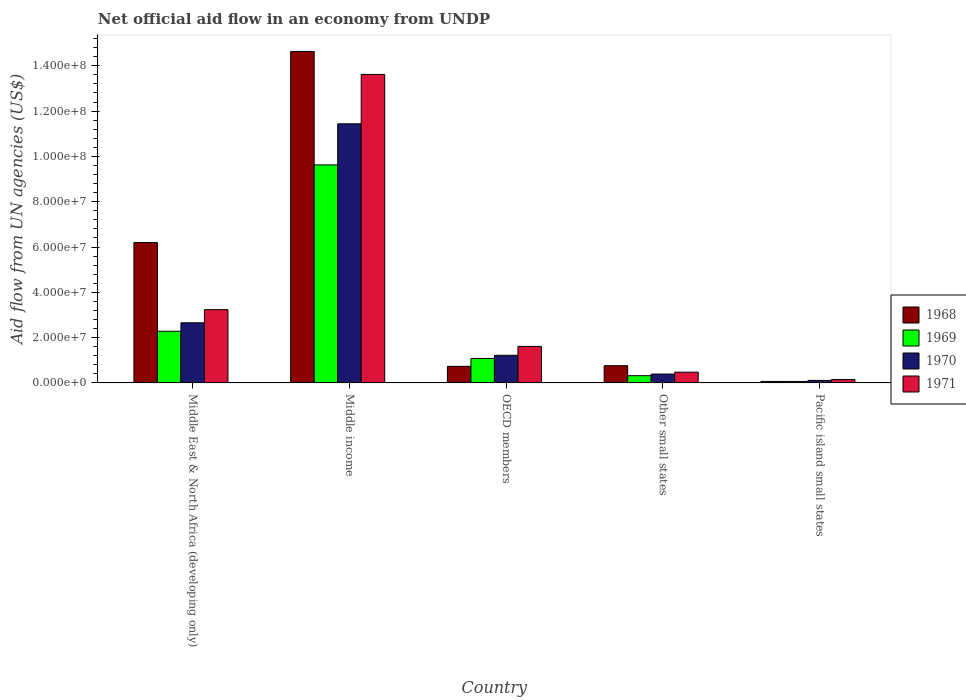How many different coloured bars are there?
Make the answer very short. 4. How many groups of bars are there?
Ensure brevity in your answer.  5. Are the number of bars per tick equal to the number of legend labels?
Ensure brevity in your answer.  Yes. Are the number of bars on each tick of the X-axis equal?
Keep it short and to the point. Yes. What is the label of the 5th group of bars from the left?
Offer a very short reply. Pacific island small states. In how many cases, is the number of bars for a given country not equal to the number of legend labels?
Offer a very short reply. 0. What is the net official aid flow in 1970 in Middle East & North Africa (developing only)?
Give a very brief answer. 2.66e+07. Across all countries, what is the maximum net official aid flow in 1970?
Ensure brevity in your answer.  1.14e+08. In which country was the net official aid flow in 1968 minimum?
Your response must be concise. Pacific island small states. What is the total net official aid flow in 1971 in the graph?
Keep it short and to the point. 1.91e+08. What is the difference between the net official aid flow in 1970 in Middle income and that in Other small states?
Keep it short and to the point. 1.10e+08. What is the difference between the net official aid flow in 1969 in Other small states and the net official aid flow in 1968 in Middle income?
Provide a short and direct response. -1.43e+08. What is the average net official aid flow in 1971 per country?
Provide a succinct answer. 3.82e+07. What is the difference between the net official aid flow of/in 1968 and net official aid flow of/in 1971 in Middle East & North Africa (developing only)?
Your response must be concise. 2.96e+07. In how many countries, is the net official aid flow in 1971 greater than 32000000 US$?
Your answer should be very brief. 2. What is the ratio of the net official aid flow in 1970 in Middle East & North Africa (developing only) to that in OECD members?
Keep it short and to the point. 2.18. Is the net official aid flow in 1969 in Other small states less than that in Pacific island small states?
Your answer should be compact. No. Is the difference between the net official aid flow in 1968 in Other small states and Pacific island small states greater than the difference between the net official aid flow in 1971 in Other small states and Pacific island small states?
Offer a terse response. Yes. What is the difference between the highest and the second highest net official aid flow in 1970?
Provide a short and direct response. 1.02e+08. What is the difference between the highest and the lowest net official aid flow in 1970?
Keep it short and to the point. 1.13e+08. What does the 3rd bar from the left in Pacific island small states represents?
Provide a succinct answer. 1970. What does the 3rd bar from the right in Pacific island small states represents?
Make the answer very short. 1969. How many countries are there in the graph?
Offer a very short reply. 5. How many legend labels are there?
Keep it short and to the point. 4. How are the legend labels stacked?
Make the answer very short. Vertical. What is the title of the graph?
Offer a terse response. Net official aid flow in an economy from UNDP. Does "2007" appear as one of the legend labels in the graph?
Offer a very short reply. No. What is the label or title of the X-axis?
Offer a very short reply. Country. What is the label or title of the Y-axis?
Provide a short and direct response. Aid flow from UN agencies (US$). What is the Aid flow from UN agencies (US$) of 1968 in Middle East & North Africa (developing only)?
Provide a short and direct response. 6.20e+07. What is the Aid flow from UN agencies (US$) of 1969 in Middle East & North Africa (developing only)?
Your answer should be very brief. 2.28e+07. What is the Aid flow from UN agencies (US$) in 1970 in Middle East & North Africa (developing only)?
Your response must be concise. 2.66e+07. What is the Aid flow from UN agencies (US$) of 1971 in Middle East & North Africa (developing only)?
Give a very brief answer. 3.24e+07. What is the Aid flow from UN agencies (US$) of 1968 in Middle income?
Offer a terse response. 1.46e+08. What is the Aid flow from UN agencies (US$) in 1969 in Middle income?
Offer a very short reply. 9.62e+07. What is the Aid flow from UN agencies (US$) of 1970 in Middle income?
Make the answer very short. 1.14e+08. What is the Aid flow from UN agencies (US$) in 1971 in Middle income?
Provide a succinct answer. 1.36e+08. What is the Aid flow from UN agencies (US$) in 1968 in OECD members?
Your answer should be very brief. 7.34e+06. What is the Aid flow from UN agencies (US$) in 1969 in OECD members?
Keep it short and to the point. 1.08e+07. What is the Aid flow from UN agencies (US$) of 1970 in OECD members?
Keep it short and to the point. 1.22e+07. What is the Aid flow from UN agencies (US$) of 1971 in OECD members?
Your response must be concise. 1.61e+07. What is the Aid flow from UN agencies (US$) in 1968 in Other small states?
Your response must be concise. 7.61e+06. What is the Aid flow from UN agencies (US$) of 1969 in Other small states?
Ensure brevity in your answer.  3.20e+06. What is the Aid flow from UN agencies (US$) in 1970 in Other small states?
Your answer should be compact. 3.93e+06. What is the Aid flow from UN agencies (US$) in 1971 in Other small states?
Provide a succinct answer. 4.76e+06. What is the Aid flow from UN agencies (US$) in 1968 in Pacific island small states?
Keep it short and to the point. 6.70e+05. What is the Aid flow from UN agencies (US$) of 1970 in Pacific island small states?
Keep it short and to the point. 1.12e+06. What is the Aid flow from UN agencies (US$) of 1971 in Pacific island small states?
Offer a terse response. 1.50e+06. Across all countries, what is the maximum Aid flow from UN agencies (US$) in 1968?
Make the answer very short. 1.46e+08. Across all countries, what is the maximum Aid flow from UN agencies (US$) of 1969?
Ensure brevity in your answer.  9.62e+07. Across all countries, what is the maximum Aid flow from UN agencies (US$) of 1970?
Offer a terse response. 1.14e+08. Across all countries, what is the maximum Aid flow from UN agencies (US$) in 1971?
Provide a succinct answer. 1.36e+08. Across all countries, what is the minimum Aid flow from UN agencies (US$) of 1968?
Provide a succinct answer. 6.70e+05. Across all countries, what is the minimum Aid flow from UN agencies (US$) of 1969?
Keep it short and to the point. 6.60e+05. Across all countries, what is the minimum Aid flow from UN agencies (US$) of 1970?
Offer a terse response. 1.12e+06. Across all countries, what is the minimum Aid flow from UN agencies (US$) in 1971?
Make the answer very short. 1.50e+06. What is the total Aid flow from UN agencies (US$) of 1968 in the graph?
Make the answer very short. 2.24e+08. What is the total Aid flow from UN agencies (US$) of 1969 in the graph?
Your answer should be very brief. 1.34e+08. What is the total Aid flow from UN agencies (US$) of 1970 in the graph?
Your response must be concise. 1.58e+08. What is the total Aid flow from UN agencies (US$) of 1971 in the graph?
Offer a terse response. 1.91e+08. What is the difference between the Aid flow from UN agencies (US$) in 1968 in Middle East & North Africa (developing only) and that in Middle income?
Your answer should be compact. -8.44e+07. What is the difference between the Aid flow from UN agencies (US$) in 1969 in Middle East & North Africa (developing only) and that in Middle income?
Provide a succinct answer. -7.34e+07. What is the difference between the Aid flow from UN agencies (US$) of 1970 in Middle East & North Africa (developing only) and that in Middle income?
Offer a terse response. -8.78e+07. What is the difference between the Aid flow from UN agencies (US$) in 1971 in Middle East & North Africa (developing only) and that in Middle income?
Your answer should be very brief. -1.04e+08. What is the difference between the Aid flow from UN agencies (US$) in 1968 in Middle East & North Africa (developing only) and that in OECD members?
Provide a short and direct response. 5.46e+07. What is the difference between the Aid flow from UN agencies (US$) of 1969 in Middle East & North Africa (developing only) and that in OECD members?
Ensure brevity in your answer.  1.20e+07. What is the difference between the Aid flow from UN agencies (US$) in 1970 in Middle East & North Africa (developing only) and that in OECD members?
Your answer should be very brief. 1.44e+07. What is the difference between the Aid flow from UN agencies (US$) in 1971 in Middle East & North Africa (developing only) and that in OECD members?
Give a very brief answer. 1.62e+07. What is the difference between the Aid flow from UN agencies (US$) of 1968 in Middle East & North Africa (developing only) and that in Other small states?
Provide a short and direct response. 5.44e+07. What is the difference between the Aid flow from UN agencies (US$) in 1969 in Middle East & North Africa (developing only) and that in Other small states?
Offer a terse response. 1.96e+07. What is the difference between the Aid flow from UN agencies (US$) in 1970 in Middle East & North Africa (developing only) and that in Other small states?
Provide a short and direct response. 2.26e+07. What is the difference between the Aid flow from UN agencies (US$) in 1971 in Middle East & North Africa (developing only) and that in Other small states?
Ensure brevity in your answer.  2.76e+07. What is the difference between the Aid flow from UN agencies (US$) of 1968 in Middle East & North Africa (developing only) and that in Pacific island small states?
Provide a short and direct response. 6.13e+07. What is the difference between the Aid flow from UN agencies (US$) in 1969 in Middle East & North Africa (developing only) and that in Pacific island small states?
Make the answer very short. 2.22e+07. What is the difference between the Aid flow from UN agencies (US$) in 1970 in Middle East & North Africa (developing only) and that in Pacific island small states?
Make the answer very short. 2.54e+07. What is the difference between the Aid flow from UN agencies (US$) of 1971 in Middle East & North Africa (developing only) and that in Pacific island small states?
Offer a very short reply. 3.09e+07. What is the difference between the Aid flow from UN agencies (US$) in 1968 in Middle income and that in OECD members?
Give a very brief answer. 1.39e+08. What is the difference between the Aid flow from UN agencies (US$) in 1969 in Middle income and that in OECD members?
Offer a very short reply. 8.54e+07. What is the difference between the Aid flow from UN agencies (US$) in 1970 in Middle income and that in OECD members?
Offer a very short reply. 1.02e+08. What is the difference between the Aid flow from UN agencies (US$) of 1971 in Middle income and that in OECD members?
Provide a short and direct response. 1.20e+08. What is the difference between the Aid flow from UN agencies (US$) in 1968 in Middle income and that in Other small states?
Keep it short and to the point. 1.39e+08. What is the difference between the Aid flow from UN agencies (US$) of 1969 in Middle income and that in Other small states?
Offer a terse response. 9.30e+07. What is the difference between the Aid flow from UN agencies (US$) in 1970 in Middle income and that in Other small states?
Keep it short and to the point. 1.10e+08. What is the difference between the Aid flow from UN agencies (US$) of 1971 in Middle income and that in Other small states?
Your answer should be compact. 1.31e+08. What is the difference between the Aid flow from UN agencies (US$) in 1968 in Middle income and that in Pacific island small states?
Give a very brief answer. 1.46e+08. What is the difference between the Aid flow from UN agencies (US$) in 1969 in Middle income and that in Pacific island small states?
Keep it short and to the point. 9.56e+07. What is the difference between the Aid flow from UN agencies (US$) in 1970 in Middle income and that in Pacific island small states?
Provide a succinct answer. 1.13e+08. What is the difference between the Aid flow from UN agencies (US$) in 1971 in Middle income and that in Pacific island small states?
Offer a very short reply. 1.35e+08. What is the difference between the Aid flow from UN agencies (US$) of 1968 in OECD members and that in Other small states?
Your answer should be compact. -2.70e+05. What is the difference between the Aid flow from UN agencies (US$) in 1969 in OECD members and that in Other small states?
Give a very brief answer. 7.61e+06. What is the difference between the Aid flow from UN agencies (US$) of 1970 in OECD members and that in Other small states?
Give a very brief answer. 8.27e+06. What is the difference between the Aid flow from UN agencies (US$) in 1971 in OECD members and that in Other small states?
Provide a succinct answer. 1.14e+07. What is the difference between the Aid flow from UN agencies (US$) in 1968 in OECD members and that in Pacific island small states?
Provide a succinct answer. 6.67e+06. What is the difference between the Aid flow from UN agencies (US$) of 1969 in OECD members and that in Pacific island small states?
Provide a succinct answer. 1.02e+07. What is the difference between the Aid flow from UN agencies (US$) of 1970 in OECD members and that in Pacific island small states?
Offer a terse response. 1.11e+07. What is the difference between the Aid flow from UN agencies (US$) of 1971 in OECD members and that in Pacific island small states?
Keep it short and to the point. 1.46e+07. What is the difference between the Aid flow from UN agencies (US$) in 1968 in Other small states and that in Pacific island small states?
Your answer should be compact. 6.94e+06. What is the difference between the Aid flow from UN agencies (US$) of 1969 in Other small states and that in Pacific island small states?
Provide a short and direct response. 2.54e+06. What is the difference between the Aid flow from UN agencies (US$) of 1970 in Other small states and that in Pacific island small states?
Make the answer very short. 2.81e+06. What is the difference between the Aid flow from UN agencies (US$) of 1971 in Other small states and that in Pacific island small states?
Your answer should be very brief. 3.26e+06. What is the difference between the Aid flow from UN agencies (US$) in 1968 in Middle East & North Africa (developing only) and the Aid flow from UN agencies (US$) in 1969 in Middle income?
Keep it short and to the point. -3.43e+07. What is the difference between the Aid flow from UN agencies (US$) in 1968 in Middle East & North Africa (developing only) and the Aid flow from UN agencies (US$) in 1970 in Middle income?
Make the answer very short. -5.24e+07. What is the difference between the Aid flow from UN agencies (US$) of 1968 in Middle East & North Africa (developing only) and the Aid flow from UN agencies (US$) of 1971 in Middle income?
Give a very brief answer. -7.42e+07. What is the difference between the Aid flow from UN agencies (US$) in 1969 in Middle East & North Africa (developing only) and the Aid flow from UN agencies (US$) in 1970 in Middle income?
Provide a succinct answer. -9.16e+07. What is the difference between the Aid flow from UN agencies (US$) of 1969 in Middle East & North Africa (developing only) and the Aid flow from UN agencies (US$) of 1971 in Middle income?
Give a very brief answer. -1.13e+08. What is the difference between the Aid flow from UN agencies (US$) in 1970 in Middle East & North Africa (developing only) and the Aid flow from UN agencies (US$) in 1971 in Middle income?
Your answer should be very brief. -1.10e+08. What is the difference between the Aid flow from UN agencies (US$) of 1968 in Middle East & North Africa (developing only) and the Aid flow from UN agencies (US$) of 1969 in OECD members?
Make the answer very short. 5.12e+07. What is the difference between the Aid flow from UN agencies (US$) in 1968 in Middle East & North Africa (developing only) and the Aid flow from UN agencies (US$) in 1970 in OECD members?
Offer a very short reply. 4.98e+07. What is the difference between the Aid flow from UN agencies (US$) of 1968 in Middle East & North Africa (developing only) and the Aid flow from UN agencies (US$) of 1971 in OECD members?
Keep it short and to the point. 4.58e+07. What is the difference between the Aid flow from UN agencies (US$) in 1969 in Middle East & North Africa (developing only) and the Aid flow from UN agencies (US$) in 1970 in OECD members?
Give a very brief answer. 1.06e+07. What is the difference between the Aid flow from UN agencies (US$) of 1969 in Middle East & North Africa (developing only) and the Aid flow from UN agencies (US$) of 1971 in OECD members?
Offer a terse response. 6.69e+06. What is the difference between the Aid flow from UN agencies (US$) in 1970 in Middle East & North Africa (developing only) and the Aid flow from UN agencies (US$) in 1971 in OECD members?
Give a very brief answer. 1.04e+07. What is the difference between the Aid flow from UN agencies (US$) of 1968 in Middle East & North Africa (developing only) and the Aid flow from UN agencies (US$) of 1969 in Other small states?
Offer a terse response. 5.88e+07. What is the difference between the Aid flow from UN agencies (US$) in 1968 in Middle East & North Africa (developing only) and the Aid flow from UN agencies (US$) in 1970 in Other small states?
Give a very brief answer. 5.80e+07. What is the difference between the Aid flow from UN agencies (US$) of 1968 in Middle East & North Africa (developing only) and the Aid flow from UN agencies (US$) of 1971 in Other small states?
Make the answer very short. 5.72e+07. What is the difference between the Aid flow from UN agencies (US$) in 1969 in Middle East & North Africa (developing only) and the Aid flow from UN agencies (US$) in 1970 in Other small states?
Give a very brief answer. 1.89e+07. What is the difference between the Aid flow from UN agencies (US$) in 1969 in Middle East & North Africa (developing only) and the Aid flow from UN agencies (US$) in 1971 in Other small states?
Make the answer very short. 1.81e+07. What is the difference between the Aid flow from UN agencies (US$) in 1970 in Middle East & North Africa (developing only) and the Aid flow from UN agencies (US$) in 1971 in Other small states?
Give a very brief answer. 2.18e+07. What is the difference between the Aid flow from UN agencies (US$) in 1968 in Middle East & North Africa (developing only) and the Aid flow from UN agencies (US$) in 1969 in Pacific island small states?
Give a very brief answer. 6.13e+07. What is the difference between the Aid flow from UN agencies (US$) of 1968 in Middle East & North Africa (developing only) and the Aid flow from UN agencies (US$) of 1970 in Pacific island small states?
Provide a short and direct response. 6.08e+07. What is the difference between the Aid flow from UN agencies (US$) in 1968 in Middle East & North Africa (developing only) and the Aid flow from UN agencies (US$) in 1971 in Pacific island small states?
Make the answer very short. 6.05e+07. What is the difference between the Aid flow from UN agencies (US$) in 1969 in Middle East & North Africa (developing only) and the Aid flow from UN agencies (US$) in 1970 in Pacific island small states?
Your response must be concise. 2.17e+07. What is the difference between the Aid flow from UN agencies (US$) in 1969 in Middle East & North Africa (developing only) and the Aid flow from UN agencies (US$) in 1971 in Pacific island small states?
Offer a terse response. 2.13e+07. What is the difference between the Aid flow from UN agencies (US$) in 1970 in Middle East & North Africa (developing only) and the Aid flow from UN agencies (US$) in 1971 in Pacific island small states?
Your answer should be very brief. 2.50e+07. What is the difference between the Aid flow from UN agencies (US$) of 1968 in Middle income and the Aid flow from UN agencies (US$) of 1969 in OECD members?
Make the answer very short. 1.36e+08. What is the difference between the Aid flow from UN agencies (US$) in 1968 in Middle income and the Aid flow from UN agencies (US$) in 1970 in OECD members?
Your response must be concise. 1.34e+08. What is the difference between the Aid flow from UN agencies (US$) of 1968 in Middle income and the Aid flow from UN agencies (US$) of 1971 in OECD members?
Make the answer very short. 1.30e+08. What is the difference between the Aid flow from UN agencies (US$) in 1969 in Middle income and the Aid flow from UN agencies (US$) in 1970 in OECD members?
Ensure brevity in your answer.  8.40e+07. What is the difference between the Aid flow from UN agencies (US$) of 1969 in Middle income and the Aid flow from UN agencies (US$) of 1971 in OECD members?
Provide a succinct answer. 8.01e+07. What is the difference between the Aid flow from UN agencies (US$) in 1970 in Middle income and the Aid flow from UN agencies (US$) in 1971 in OECD members?
Give a very brief answer. 9.83e+07. What is the difference between the Aid flow from UN agencies (US$) of 1968 in Middle income and the Aid flow from UN agencies (US$) of 1969 in Other small states?
Your answer should be very brief. 1.43e+08. What is the difference between the Aid flow from UN agencies (US$) in 1968 in Middle income and the Aid flow from UN agencies (US$) in 1970 in Other small states?
Make the answer very short. 1.42e+08. What is the difference between the Aid flow from UN agencies (US$) in 1968 in Middle income and the Aid flow from UN agencies (US$) in 1971 in Other small states?
Offer a very short reply. 1.42e+08. What is the difference between the Aid flow from UN agencies (US$) in 1969 in Middle income and the Aid flow from UN agencies (US$) in 1970 in Other small states?
Make the answer very short. 9.23e+07. What is the difference between the Aid flow from UN agencies (US$) of 1969 in Middle income and the Aid flow from UN agencies (US$) of 1971 in Other small states?
Provide a succinct answer. 9.15e+07. What is the difference between the Aid flow from UN agencies (US$) in 1970 in Middle income and the Aid flow from UN agencies (US$) in 1971 in Other small states?
Offer a terse response. 1.10e+08. What is the difference between the Aid flow from UN agencies (US$) of 1968 in Middle income and the Aid flow from UN agencies (US$) of 1969 in Pacific island small states?
Offer a terse response. 1.46e+08. What is the difference between the Aid flow from UN agencies (US$) in 1968 in Middle income and the Aid flow from UN agencies (US$) in 1970 in Pacific island small states?
Keep it short and to the point. 1.45e+08. What is the difference between the Aid flow from UN agencies (US$) of 1968 in Middle income and the Aid flow from UN agencies (US$) of 1971 in Pacific island small states?
Your answer should be compact. 1.45e+08. What is the difference between the Aid flow from UN agencies (US$) in 1969 in Middle income and the Aid flow from UN agencies (US$) in 1970 in Pacific island small states?
Ensure brevity in your answer.  9.51e+07. What is the difference between the Aid flow from UN agencies (US$) of 1969 in Middle income and the Aid flow from UN agencies (US$) of 1971 in Pacific island small states?
Offer a terse response. 9.48e+07. What is the difference between the Aid flow from UN agencies (US$) in 1970 in Middle income and the Aid flow from UN agencies (US$) in 1971 in Pacific island small states?
Give a very brief answer. 1.13e+08. What is the difference between the Aid flow from UN agencies (US$) in 1968 in OECD members and the Aid flow from UN agencies (US$) in 1969 in Other small states?
Your response must be concise. 4.14e+06. What is the difference between the Aid flow from UN agencies (US$) in 1968 in OECD members and the Aid flow from UN agencies (US$) in 1970 in Other small states?
Your answer should be very brief. 3.41e+06. What is the difference between the Aid flow from UN agencies (US$) in 1968 in OECD members and the Aid flow from UN agencies (US$) in 1971 in Other small states?
Provide a succinct answer. 2.58e+06. What is the difference between the Aid flow from UN agencies (US$) in 1969 in OECD members and the Aid flow from UN agencies (US$) in 1970 in Other small states?
Provide a short and direct response. 6.88e+06. What is the difference between the Aid flow from UN agencies (US$) in 1969 in OECD members and the Aid flow from UN agencies (US$) in 1971 in Other small states?
Your answer should be very brief. 6.05e+06. What is the difference between the Aid flow from UN agencies (US$) in 1970 in OECD members and the Aid flow from UN agencies (US$) in 1971 in Other small states?
Make the answer very short. 7.44e+06. What is the difference between the Aid flow from UN agencies (US$) in 1968 in OECD members and the Aid flow from UN agencies (US$) in 1969 in Pacific island small states?
Provide a succinct answer. 6.68e+06. What is the difference between the Aid flow from UN agencies (US$) of 1968 in OECD members and the Aid flow from UN agencies (US$) of 1970 in Pacific island small states?
Make the answer very short. 6.22e+06. What is the difference between the Aid flow from UN agencies (US$) of 1968 in OECD members and the Aid flow from UN agencies (US$) of 1971 in Pacific island small states?
Provide a succinct answer. 5.84e+06. What is the difference between the Aid flow from UN agencies (US$) of 1969 in OECD members and the Aid flow from UN agencies (US$) of 1970 in Pacific island small states?
Provide a succinct answer. 9.69e+06. What is the difference between the Aid flow from UN agencies (US$) in 1969 in OECD members and the Aid flow from UN agencies (US$) in 1971 in Pacific island small states?
Provide a short and direct response. 9.31e+06. What is the difference between the Aid flow from UN agencies (US$) of 1970 in OECD members and the Aid flow from UN agencies (US$) of 1971 in Pacific island small states?
Offer a terse response. 1.07e+07. What is the difference between the Aid flow from UN agencies (US$) of 1968 in Other small states and the Aid flow from UN agencies (US$) of 1969 in Pacific island small states?
Offer a very short reply. 6.95e+06. What is the difference between the Aid flow from UN agencies (US$) in 1968 in Other small states and the Aid flow from UN agencies (US$) in 1970 in Pacific island small states?
Keep it short and to the point. 6.49e+06. What is the difference between the Aid flow from UN agencies (US$) in 1968 in Other small states and the Aid flow from UN agencies (US$) in 1971 in Pacific island small states?
Provide a short and direct response. 6.11e+06. What is the difference between the Aid flow from UN agencies (US$) in 1969 in Other small states and the Aid flow from UN agencies (US$) in 1970 in Pacific island small states?
Provide a succinct answer. 2.08e+06. What is the difference between the Aid flow from UN agencies (US$) of 1969 in Other small states and the Aid flow from UN agencies (US$) of 1971 in Pacific island small states?
Provide a succinct answer. 1.70e+06. What is the difference between the Aid flow from UN agencies (US$) of 1970 in Other small states and the Aid flow from UN agencies (US$) of 1971 in Pacific island small states?
Your answer should be very brief. 2.43e+06. What is the average Aid flow from UN agencies (US$) of 1968 per country?
Offer a terse response. 4.48e+07. What is the average Aid flow from UN agencies (US$) of 1969 per country?
Offer a terse response. 2.67e+07. What is the average Aid flow from UN agencies (US$) of 1970 per country?
Provide a succinct answer. 3.16e+07. What is the average Aid flow from UN agencies (US$) of 1971 per country?
Make the answer very short. 3.82e+07. What is the difference between the Aid flow from UN agencies (US$) in 1968 and Aid flow from UN agencies (US$) in 1969 in Middle East & North Africa (developing only)?
Offer a terse response. 3.92e+07. What is the difference between the Aid flow from UN agencies (US$) in 1968 and Aid flow from UN agencies (US$) in 1970 in Middle East & North Africa (developing only)?
Your answer should be very brief. 3.54e+07. What is the difference between the Aid flow from UN agencies (US$) of 1968 and Aid flow from UN agencies (US$) of 1971 in Middle East & North Africa (developing only)?
Keep it short and to the point. 2.96e+07. What is the difference between the Aid flow from UN agencies (US$) of 1969 and Aid flow from UN agencies (US$) of 1970 in Middle East & North Africa (developing only)?
Your response must be concise. -3.73e+06. What is the difference between the Aid flow from UN agencies (US$) in 1969 and Aid flow from UN agencies (US$) in 1971 in Middle East & North Africa (developing only)?
Your response must be concise. -9.54e+06. What is the difference between the Aid flow from UN agencies (US$) in 1970 and Aid flow from UN agencies (US$) in 1971 in Middle East & North Africa (developing only)?
Offer a terse response. -5.81e+06. What is the difference between the Aid flow from UN agencies (US$) in 1968 and Aid flow from UN agencies (US$) in 1969 in Middle income?
Your answer should be very brief. 5.01e+07. What is the difference between the Aid flow from UN agencies (US$) in 1968 and Aid flow from UN agencies (US$) in 1970 in Middle income?
Your answer should be compact. 3.19e+07. What is the difference between the Aid flow from UN agencies (US$) of 1968 and Aid flow from UN agencies (US$) of 1971 in Middle income?
Give a very brief answer. 1.01e+07. What is the difference between the Aid flow from UN agencies (US$) of 1969 and Aid flow from UN agencies (US$) of 1970 in Middle income?
Keep it short and to the point. -1.82e+07. What is the difference between the Aid flow from UN agencies (US$) in 1969 and Aid flow from UN agencies (US$) in 1971 in Middle income?
Your answer should be compact. -4.00e+07. What is the difference between the Aid flow from UN agencies (US$) in 1970 and Aid flow from UN agencies (US$) in 1971 in Middle income?
Keep it short and to the point. -2.18e+07. What is the difference between the Aid flow from UN agencies (US$) of 1968 and Aid flow from UN agencies (US$) of 1969 in OECD members?
Your answer should be compact. -3.47e+06. What is the difference between the Aid flow from UN agencies (US$) of 1968 and Aid flow from UN agencies (US$) of 1970 in OECD members?
Make the answer very short. -4.86e+06. What is the difference between the Aid flow from UN agencies (US$) in 1968 and Aid flow from UN agencies (US$) in 1971 in OECD members?
Give a very brief answer. -8.79e+06. What is the difference between the Aid flow from UN agencies (US$) in 1969 and Aid flow from UN agencies (US$) in 1970 in OECD members?
Provide a succinct answer. -1.39e+06. What is the difference between the Aid flow from UN agencies (US$) of 1969 and Aid flow from UN agencies (US$) of 1971 in OECD members?
Your answer should be compact. -5.32e+06. What is the difference between the Aid flow from UN agencies (US$) in 1970 and Aid flow from UN agencies (US$) in 1971 in OECD members?
Provide a succinct answer. -3.93e+06. What is the difference between the Aid flow from UN agencies (US$) of 1968 and Aid flow from UN agencies (US$) of 1969 in Other small states?
Offer a terse response. 4.41e+06. What is the difference between the Aid flow from UN agencies (US$) of 1968 and Aid flow from UN agencies (US$) of 1970 in Other small states?
Offer a terse response. 3.68e+06. What is the difference between the Aid flow from UN agencies (US$) of 1968 and Aid flow from UN agencies (US$) of 1971 in Other small states?
Keep it short and to the point. 2.85e+06. What is the difference between the Aid flow from UN agencies (US$) of 1969 and Aid flow from UN agencies (US$) of 1970 in Other small states?
Provide a succinct answer. -7.30e+05. What is the difference between the Aid flow from UN agencies (US$) of 1969 and Aid flow from UN agencies (US$) of 1971 in Other small states?
Make the answer very short. -1.56e+06. What is the difference between the Aid flow from UN agencies (US$) of 1970 and Aid flow from UN agencies (US$) of 1971 in Other small states?
Your answer should be compact. -8.30e+05. What is the difference between the Aid flow from UN agencies (US$) in 1968 and Aid flow from UN agencies (US$) in 1969 in Pacific island small states?
Your answer should be compact. 10000. What is the difference between the Aid flow from UN agencies (US$) in 1968 and Aid flow from UN agencies (US$) in 1970 in Pacific island small states?
Offer a terse response. -4.50e+05. What is the difference between the Aid flow from UN agencies (US$) of 1968 and Aid flow from UN agencies (US$) of 1971 in Pacific island small states?
Keep it short and to the point. -8.30e+05. What is the difference between the Aid flow from UN agencies (US$) of 1969 and Aid flow from UN agencies (US$) of 1970 in Pacific island small states?
Provide a succinct answer. -4.60e+05. What is the difference between the Aid flow from UN agencies (US$) of 1969 and Aid flow from UN agencies (US$) of 1971 in Pacific island small states?
Your answer should be very brief. -8.40e+05. What is the difference between the Aid flow from UN agencies (US$) of 1970 and Aid flow from UN agencies (US$) of 1971 in Pacific island small states?
Provide a succinct answer. -3.80e+05. What is the ratio of the Aid flow from UN agencies (US$) of 1968 in Middle East & North Africa (developing only) to that in Middle income?
Offer a terse response. 0.42. What is the ratio of the Aid flow from UN agencies (US$) in 1969 in Middle East & North Africa (developing only) to that in Middle income?
Provide a succinct answer. 0.24. What is the ratio of the Aid flow from UN agencies (US$) of 1970 in Middle East & North Africa (developing only) to that in Middle income?
Keep it short and to the point. 0.23. What is the ratio of the Aid flow from UN agencies (US$) of 1971 in Middle East & North Africa (developing only) to that in Middle income?
Your response must be concise. 0.24. What is the ratio of the Aid flow from UN agencies (US$) in 1968 in Middle East & North Africa (developing only) to that in OECD members?
Ensure brevity in your answer.  8.44. What is the ratio of the Aid flow from UN agencies (US$) in 1969 in Middle East & North Africa (developing only) to that in OECD members?
Offer a terse response. 2.11. What is the ratio of the Aid flow from UN agencies (US$) of 1970 in Middle East & North Africa (developing only) to that in OECD members?
Keep it short and to the point. 2.18. What is the ratio of the Aid flow from UN agencies (US$) in 1971 in Middle East & North Africa (developing only) to that in OECD members?
Provide a short and direct response. 2.01. What is the ratio of the Aid flow from UN agencies (US$) in 1968 in Middle East & North Africa (developing only) to that in Other small states?
Provide a succinct answer. 8.14. What is the ratio of the Aid flow from UN agencies (US$) in 1969 in Middle East & North Africa (developing only) to that in Other small states?
Your answer should be very brief. 7.13. What is the ratio of the Aid flow from UN agencies (US$) in 1970 in Middle East & North Africa (developing only) to that in Other small states?
Keep it short and to the point. 6.76. What is the ratio of the Aid flow from UN agencies (US$) of 1971 in Middle East & North Africa (developing only) to that in Other small states?
Your answer should be very brief. 6.8. What is the ratio of the Aid flow from UN agencies (US$) of 1968 in Middle East & North Africa (developing only) to that in Pacific island small states?
Your answer should be very brief. 92.49. What is the ratio of the Aid flow from UN agencies (US$) in 1969 in Middle East & North Africa (developing only) to that in Pacific island small states?
Provide a short and direct response. 34.58. What is the ratio of the Aid flow from UN agencies (US$) of 1970 in Middle East & North Africa (developing only) to that in Pacific island small states?
Ensure brevity in your answer.  23.71. What is the ratio of the Aid flow from UN agencies (US$) of 1971 in Middle East & North Africa (developing only) to that in Pacific island small states?
Your answer should be very brief. 21.57. What is the ratio of the Aid flow from UN agencies (US$) in 1968 in Middle income to that in OECD members?
Make the answer very short. 19.94. What is the ratio of the Aid flow from UN agencies (US$) of 1969 in Middle income to that in OECD members?
Ensure brevity in your answer.  8.9. What is the ratio of the Aid flow from UN agencies (US$) in 1970 in Middle income to that in OECD members?
Offer a terse response. 9.38. What is the ratio of the Aid flow from UN agencies (US$) of 1971 in Middle income to that in OECD members?
Your answer should be compact. 8.44. What is the ratio of the Aid flow from UN agencies (US$) of 1968 in Middle income to that in Other small states?
Keep it short and to the point. 19.23. What is the ratio of the Aid flow from UN agencies (US$) of 1969 in Middle income to that in Other small states?
Offer a very short reply. 30.08. What is the ratio of the Aid flow from UN agencies (US$) in 1970 in Middle income to that in Other small states?
Provide a succinct answer. 29.11. What is the ratio of the Aid flow from UN agencies (US$) in 1971 in Middle income to that in Other small states?
Keep it short and to the point. 28.61. What is the ratio of the Aid flow from UN agencies (US$) in 1968 in Middle income to that in Pacific island small states?
Ensure brevity in your answer.  218.42. What is the ratio of the Aid flow from UN agencies (US$) in 1969 in Middle income to that in Pacific island small states?
Keep it short and to the point. 145.83. What is the ratio of the Aid flow from UN agencies (US$) of 1970 in Middle income to that in Pacific island small states?
Offer a very short reply. 102.14. What is the ratio of the Aid flow from UN agencies (US$) in 1971 in Middle income to that in Pacific island small states?
Offer a terse response. 90.8. What is the ratio of the Aid flow from UN agencies (US$) of 1968 in OECD members to that in Other small states?
Your response must be concise. 0.96. What is the ratio of the Aid flow from UN agencies (US$) in 1969 in OECD members to that in Other small states?
Offer a very short reply. 3.38. What is the ratio of the Aid flow from UN agencies (US$) in 1970 in OECD members to that in Other small states?
Give a very brief answer. 3.1. What is the ratio of the Aid flow from UN agencies (US$) of 1971 in OECD members to that in Other small states?
Your answer should be very brief. 3.39. What is the ratio of the Aid flow from UN agencies (US$) of 1968 in OECD members to that in Pacific island small states?
Your answer should be very brief. 10.96. What is the ratio of the Aid flow from UN agencies (US$) of 1969 in OECD members to that in Pacific island small states?
Your answer should be very brief. 16.38. What is the ratio of the Aid flow from UN agencies (US$) in 1970 in OECD members to that in Pacific island small states?
Make the answer very short. 10.89. What is the ratio of the Aid flow from UN agencies (US$) of 1971 in OECD members to that in Pacific island small states?
Offer a very short reply. 10.75. What is the ratio of the Aid flow from UN agencies (US$) of 1968 in Other small states to that in Pacific island small states?
Your response must be concise. 11.36. What is the ratio of the Aid flow from UN agencies (US$) in 1969 in Other small states to that in Pacific island small states?
Give a very brief answer. 4.85. What is the ratio of the Aid flow from UN agencies (US$) of 1970 in Other small states to that in Pacific island small states?
Your answer should be very brief. 3.51. What is the ratio of the Aid flow from UN agencies (US$) of 1971 in Other small states to that in Pacific island small states?
Your response must be concise. 3.17. What is the difference between the highest and the second highest Aid flow from UN agencies (US$) in 1968?
Make the answer very short. 8.44e+07. What is the difference between the highest and the second highest Aid flow from UN agencies (US$) in 1969?
Give a very brief answer. 7.34e+07. What is the difference between the highest and the second highest Aid flow from UN agencies (US$) in 1970?
Provide a succinct answer. 8.78e+07. What is the difference between the highest and the second highest Aid flow from UN agencies (US$) in 1971?
Give a very brief answer. 1.04e+08. What is the difference between the highest and the lowest Aid flow from UN agencies (US$) in 1968?
Offer a terse response. 1.46e+08. What is the difference between the highest and the lowest Aid flow from UN agencies (US$) in 1969?
Keep it short and to the point. 9.56e+07. What is the difference between the highest and the lowest Aid flow from UN agencies (US$) in 1970?
Your response must be concise. 1.13e+08. What is the difference between the highest and the lowest Aid flow from UN agencies (US$) of 1971?
Give a very brief answer. 1.35e+08. 